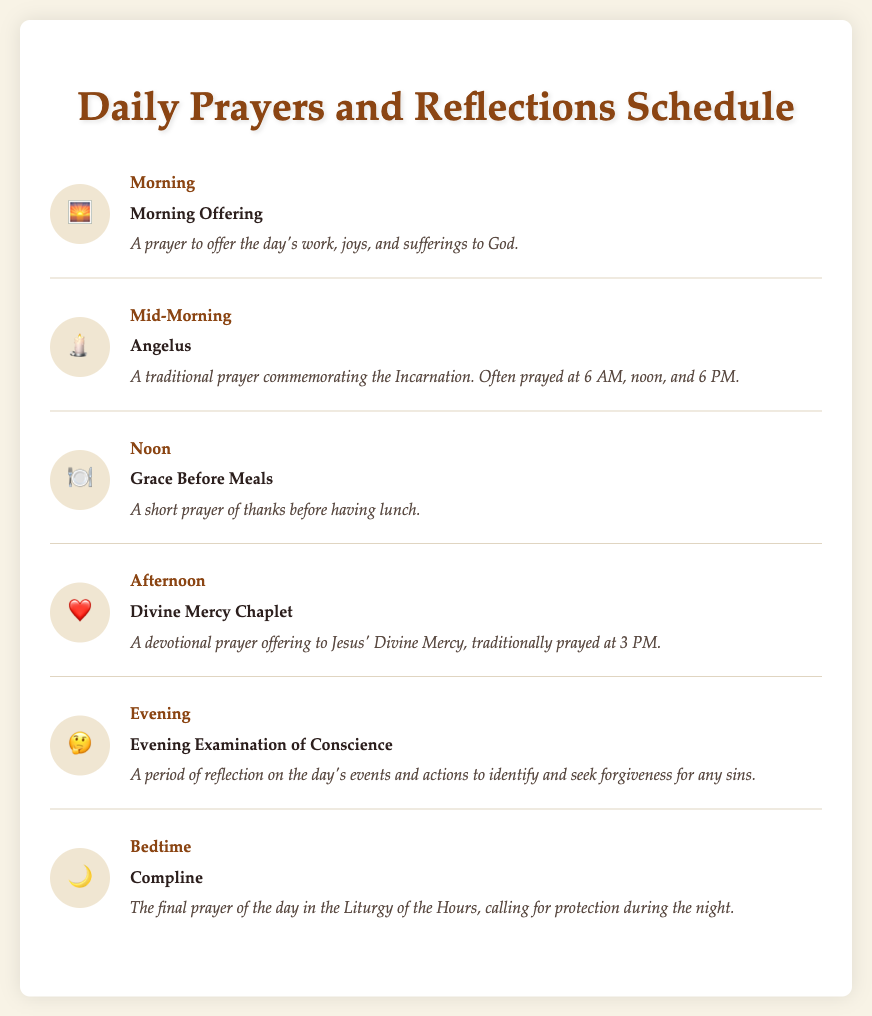What is the first prayer listed? The first prayer in the list is the Morning Offering, indicated by the rising sun icon.
Answer: Morning Offering What time is the Divine Mercy Chaplet prayed? The Divine Mercy Chaplet is traditionally prayed at 3 PM, as noted in the document.
Answer: 3 PM How many prayer types are included in the document? The document lists a total of six different types of prayers.
Answer: Six What does the icon of the heart represent? The heart icon represents the Divine Mercy Chaplet, as shown in the prayer item description.
Answer: Divine Mercy Chaplet Which prayer is associated with the meal time? The prayer associated with mealtime is Grace Before Meals, as outlined in the noon section.
Answer: Grace Before Meals What is the purpose of the Evening Examination of Conscience? The Evening Examination of Conscience is meant for reflection on the day's events and seeking forgiveness for sins.
Answer: Reflection and forgiveness Which prayer is recited at bedtime? The prayer recited at bedtime is Compline, indicated by the moon icon.
Answer: Compline What is the traditional time to pray the Angelus? The Angelus is traditionally prayed at 6 AM, noon, and 6 PM, as specified in its description.
Answer: 6 AM, noon, and 6 PM 